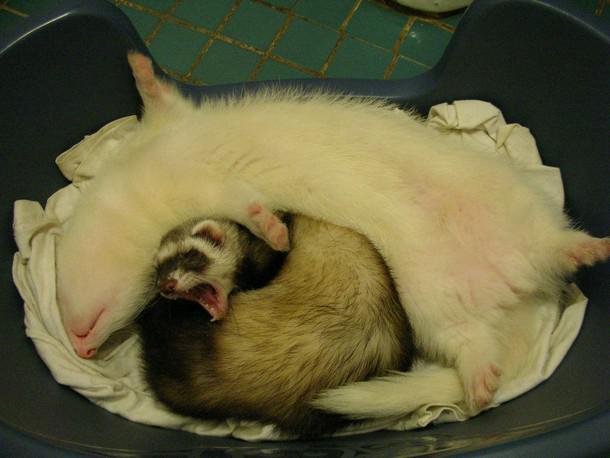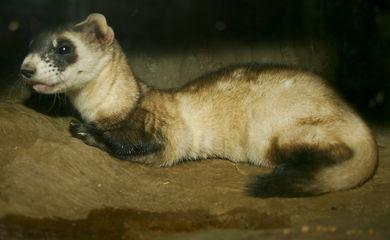The first image is the image on the left, the second image is the image on the right. For the images displayed, is the sentence "There is a ferret in the outdoors looking directly at the camera in the right image." factually correct? Answer yes or no. No. 